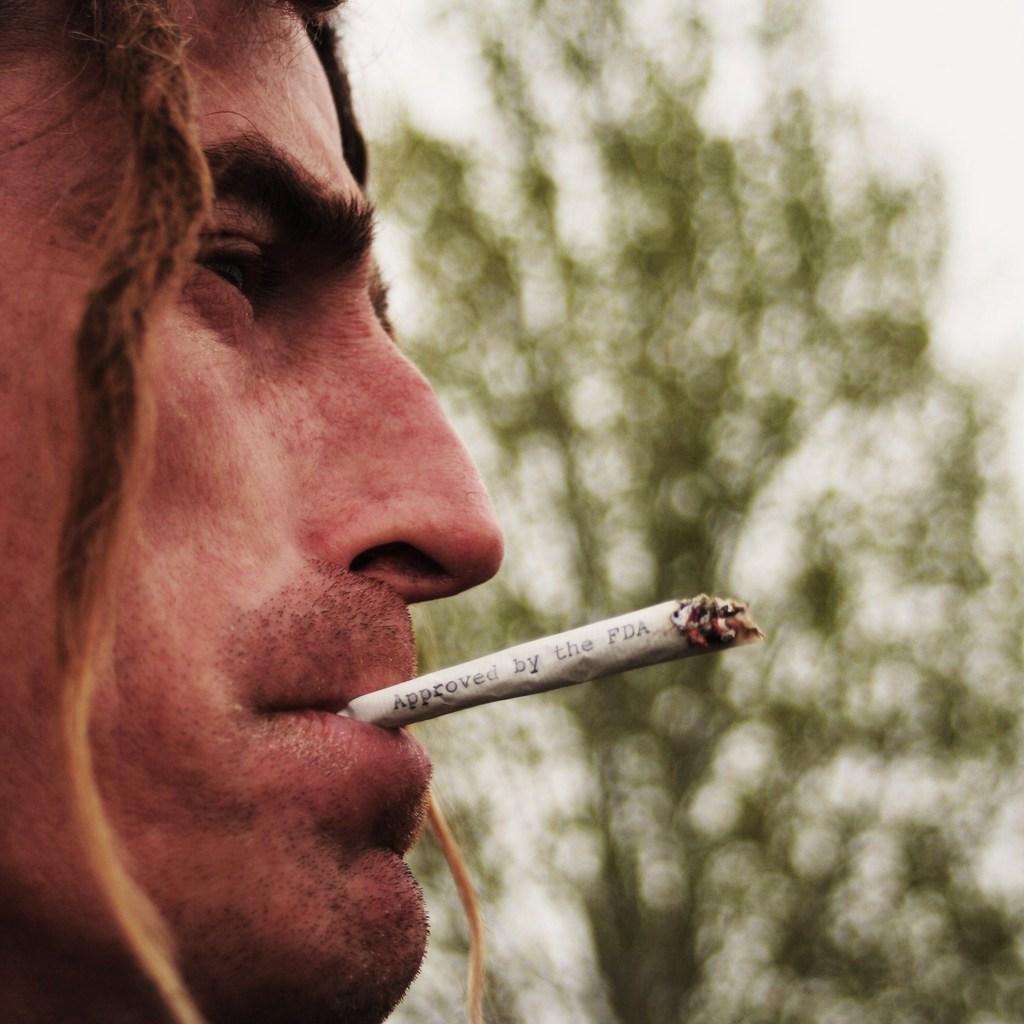Describe this image in one or two sentences. This is a zoomed in picture. In the foreground there is a person holding a cigarette in his mouth. In the background we can see the sky and a tree. 